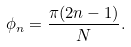Convert formula to latex. <formula><loc_0><loc_0><loc_500><loc_500>\phi _ { n } = \frac { \pi ( 2 n - 1 ) } { N } .</formula> 